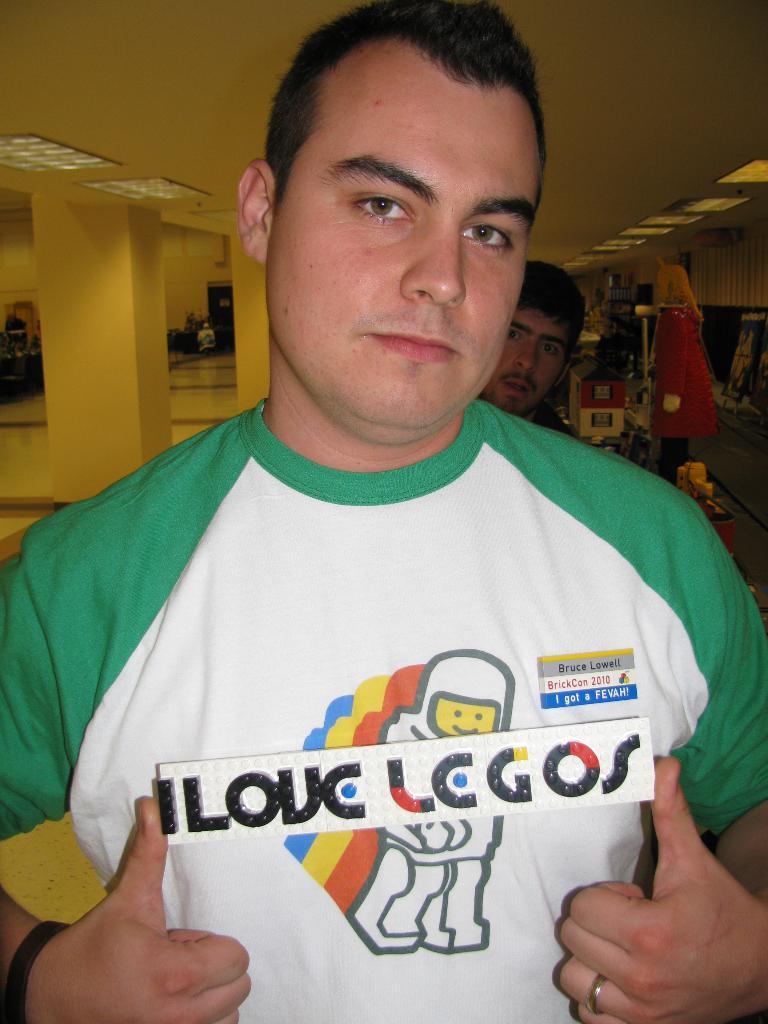What does his name tag say?
Your answer should be compact. I love legos. 